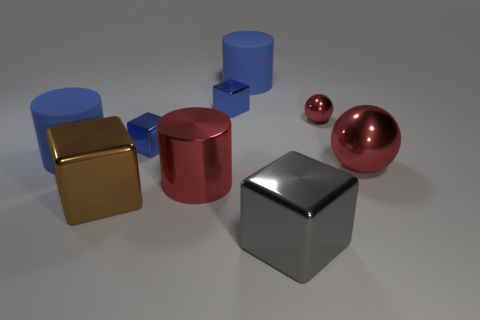Add 1 red spheres. How many objects exist? 10 Subtract all cubes. How many objects are left? 5 Add 1 big gray shiny things. How many big gray shiny things exist? 2 Subtract 0 cyan cylinders. How many objects are left? 9 Subtract all large shiny blocks. Subtract all shiny things. How many objects are left? 0 Add 9 brown things. How many brown things are left? 10 